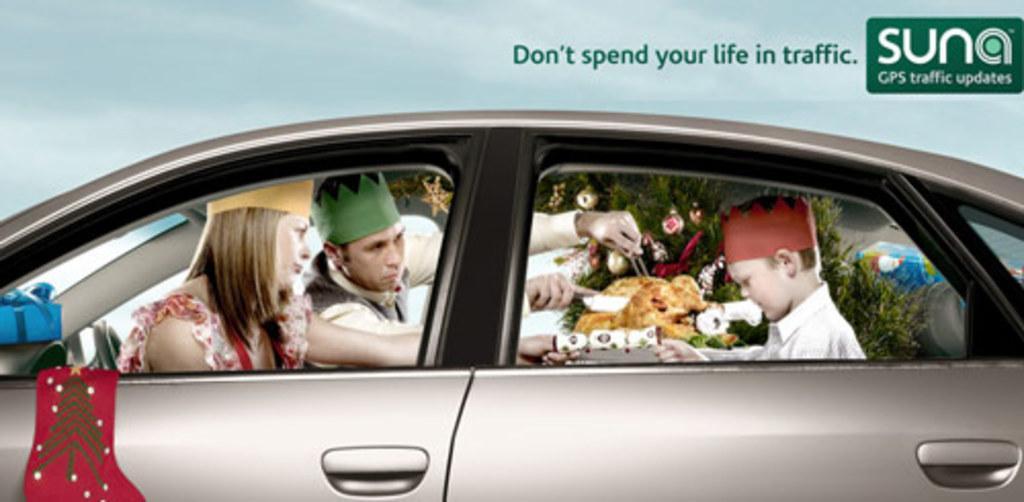How would you summarize this image in a sentence or two? In this picture we can see one poster. And there are three persons in the car and this is some food. 